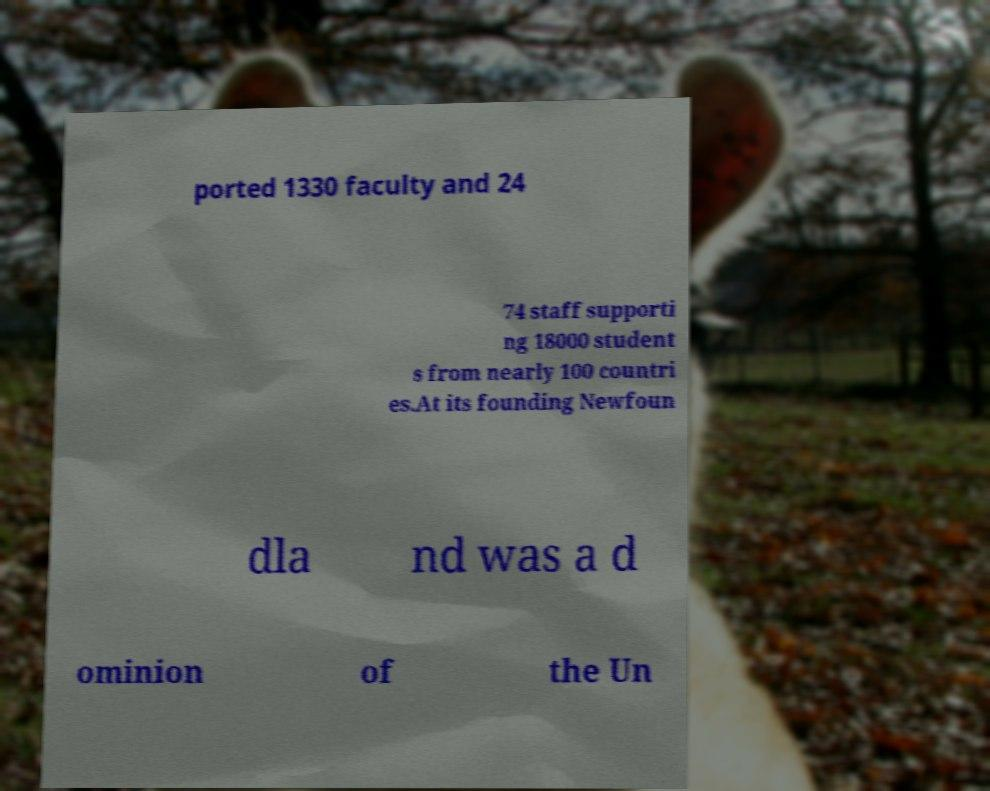For documentation purposes, I need the text within this image transcribed. Could you provide that? ported 1330 faculty and 24 74 staff supporti ng 18000 student s from nearly 100 countri es.At its founding Newfoun dla nd was a d ominion of the Un 